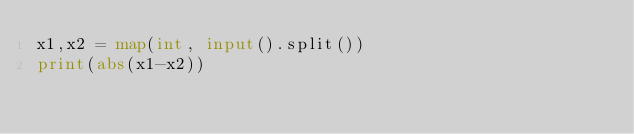<code> <loc_0><loc_0><loc_500><loc_500><_Python_>x1,x2 = map(int, input().split())
print(abs(x1-x2))
</code> 